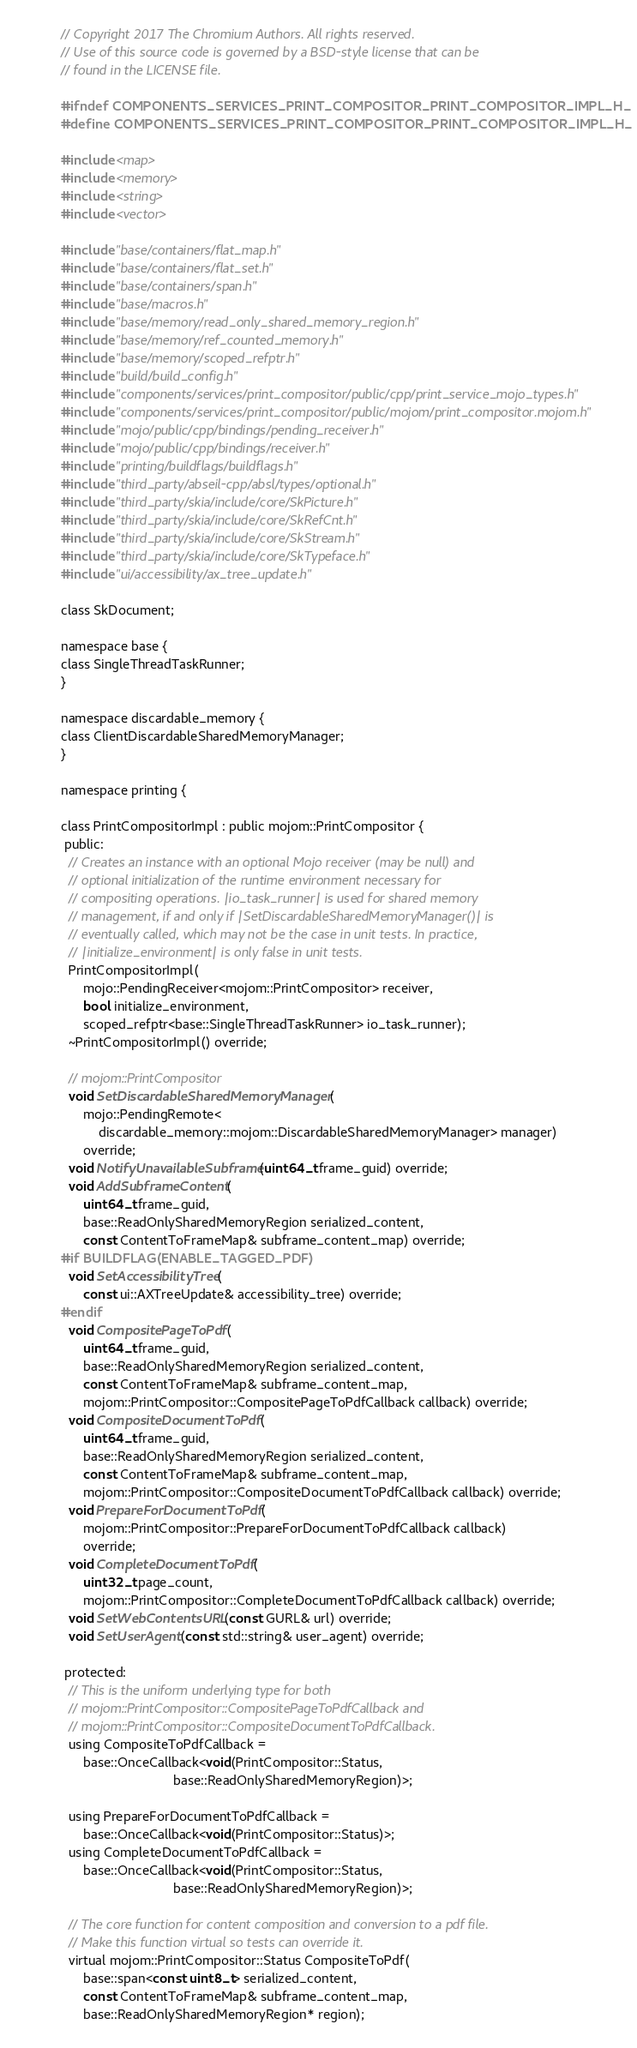Convert code to text. <code><loc_0><loc_0><loc_500><loc_500><_C_>// Copyright 2017 The Chromium Authors. All rights reserved.
// Use of this source code is governed by a BSD-style license that can be
// found in the LICENSE file.

#ifndef COMPONENTS_SERVICES_PRINT_COMPOSITOR_PRINT_COMPOSITOR_IMPL_H_
#define COMPONENTS_SERVICES_PRINT_COMPOSITOR_PRINT_COMPOSITOR_IMPL_H_

#include <map>
#include <memory>
#include <string>
#include <vector>

#include "base/containers/flat_map.h"
#include "base/containers/flat_set.h"
#include "base/containers/span.h"
#include "base/macros.h"
#include "base/memory/read_only_shared_memory_region.h"
#include "base/memory/ref_counted_memory.h"
#include "base/memory/scoped_refptr.h"
#include "build/build_config.h"
#include "components/services/print_compositor/public/cpp/print_service_mojo_types.h"
#include "components/services/print_compositor/public/mojom/print_compositor.mojom.h"
#include "mojo/public/cpp/bindings/pending_receiver.h"
#include "mojo/public/cpp/bindings/receiver.h"
#include "printing/buildflags/buildflags.h"
#include "third_party/abseil-cpp/absl/types/optional.h"
#include "third_party/skia/include/core/SkPicture.h"
#include "third_party/skia/include/core/SkRefCnt.h"
#include "third_party/skia/include/core/SkStream.h"
#include "third_party/skia/include/core/SkTypeface.h"
#include "ui/accessibility/ax_tree_update.h"

class SkDocument;

namespace base {
class SingleThreadTaskRunner;
}

namespace discardable_memory {
class ClientDiscardableSharedMemoryManager;
}

namespace printing {

class PrintCompositorImpl : public mojom::PrintCompositor {
 public:
  // Creates an instance with an optional Mojo receiver (may be null) and
  // optional initialization of the runtime environment necessary for
  // compositing operations. |io_task_runner| is used for shared memory
  // management, if and only if |SetDiscardableSharedMemoryManager()| is
  // eventually called, which may not be the case in unit tests. In practice,
  // |initialize_environment| is only false in unit tests.
  PrintCompositorImpl(
      mojo::PendingReceiver<mojom::PrintCompositor> receiver,
      bool initialize_environment,
      scoped_refptr<base::SingleThreadTaskRunner> io_task_runner);
  ~PrintCompositorImpl() override;

  // mojom::PrintCompositor
  void SetDiscardableSharedMemoryManager(
      mojo::PendingRemote<
          discardable_memory::mojom::DiscardableSharedMemoryManager> manager)
      override;
  void NotifyUnavailableSubframe(uint64_t frame_guid) override;
  void AddSubframeContent(
      uint64_t frame_guid,
      base::ReadOnlySharedMemoryRegion serialized_content,
      const ContentToFrameMap& subframe_content_map) override;
#if BUILDFLAG(ENABLE_TAGGED_PDF)
  void SetAccessibilityTree(
      const ui::AXTreeUpdate& accessibility_tree) override;
#endif
  void CompositePageToPdf(
      uint64_t frame_guid,
      base::ReadOnlySharedMemoryRegion serialized_content,
      const ContentToFrameMap& subframe_content_map,
      mojom::PrintCompositor::CompositePageToPdfCallback callback) override;
  void CompositeDocumentToPdf(
      uint64_t frame_guid,
      base::ReadOnlySharedMemoryRegion serialized_content,
      const ContentToFrameMap& subframe_content_map,
      mojom::PrintCompositor::CompositeDocumentToPdfCallback callback) override;
  void PrepareForDocumentToPdf(
      mojom::PrintCompositor::PrepareForDocumentToPdfCallback callback)
      override;
  void CompleteDocumentToPdf(
      uint32_t page_count,
      mojom::PrintCompositor::CompleteDocumentToPdfCallback callback) override;
  void SetWebContentsURL(const GURL& url) override;
  void SetUserAgent(const std::string& user_agent) override;

 protected:
  // This is the uniform underlying type for both
  // mojom::PrintCompositor::CompositePageToPdfCallback and
  // mojom::PrintCompositor::CompositeDocumentToPdfCallback.
  using CompositeToPdfCallback =
      base::OnceCallback<void(PrintCompositor::Status,
                              base::ReadOnlySharedMemoryRegion)>;

  using PrepareForDocumentToPdfCallback =
      base::OnceCallback<void(PrintCompositor::Status)>;
  using CompleteDocumentToPdfCallback =
      base::OnceCallback<void(PrintCompositor::Status,
                              base::ReadOnlySharedMemoryRegion)>;

  // The core function for content composition and conversion to a pdf file.
  // Make this function virtual so tests can override it.
  virtual mojom::PrintCompositor::Status CompositeToPdf(
      base::span<const uint8_t> serialized_content,
      const ContentToFrameMap& subframe_content_map,
      base::ReadOnlySharedMemoryRegion* region);
</code> 